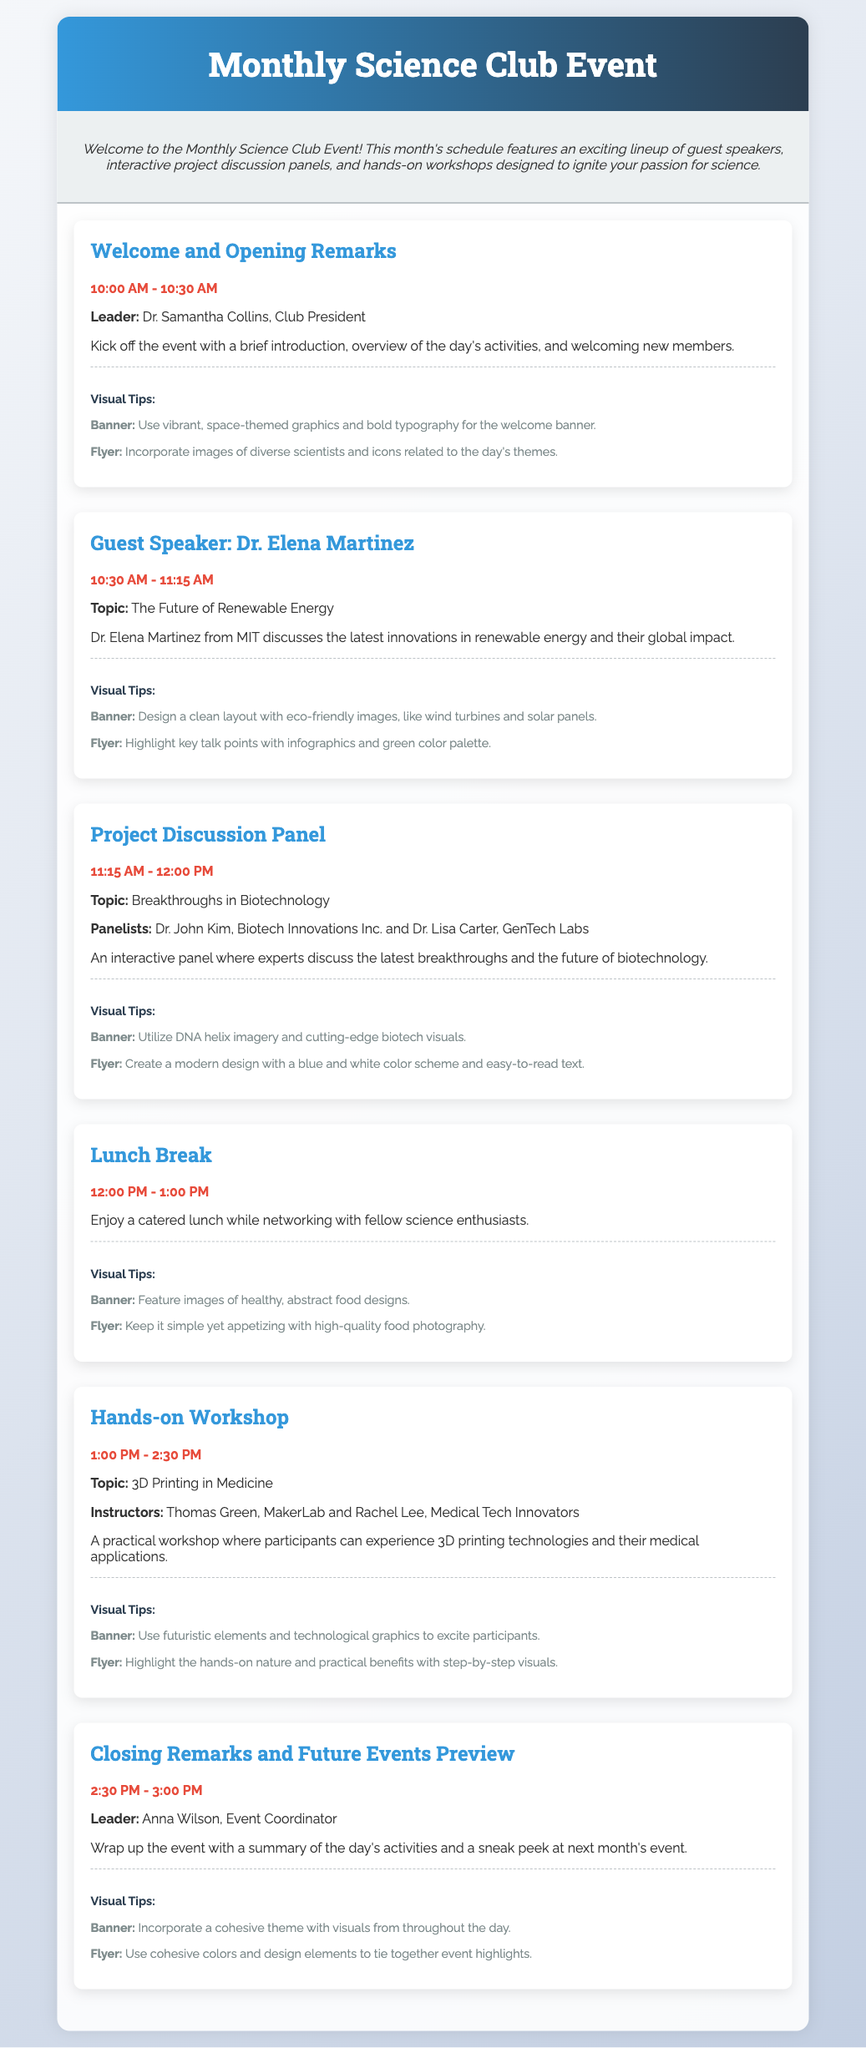What is the start time of the event? The start time of the event is mentioned in the schedule under "Welcome and Opening Remarks."
Answer: 10:00 AM Who is the guest speaker on renewable energy? The document specifies Dr. Elena Martinez as the guest speaker discussing renewable energy.
Answer: Dr. Elena Martinez What is the topic of the hands-on workshop? The workshop topic is found in the schedule section for "Hands-on Workshop."
Answer: 3D Printing in Medicine What is the duration of the lunch break? The duration of lunch break is clearly listed in the schedule.
Answer: 1 hour How many panelists are involved in the Project Discussion Panel? The panelists' count can be determined from the information provided about the event.
Answer: 2 panelists What color palette is suggested for the flyer of the guest speaker? The advised color palette is included in the visual tips for the guest speaker section.
Answer: Green color palette What is the concluding time for the event? The end time is noted in the schedule under "Closing Remarks and Future Events Preview."
Answer: 3:00 PM Which leader is responsible for the opening remarks? The leader is stated in the event details for the opening remarks section.
Answer: Dr. Samantha Collins What type of visuals are suggested for the lunch break banner? This information is found in the visual tips for the lunch break event.
Answer: Healthy, abstract food designs 